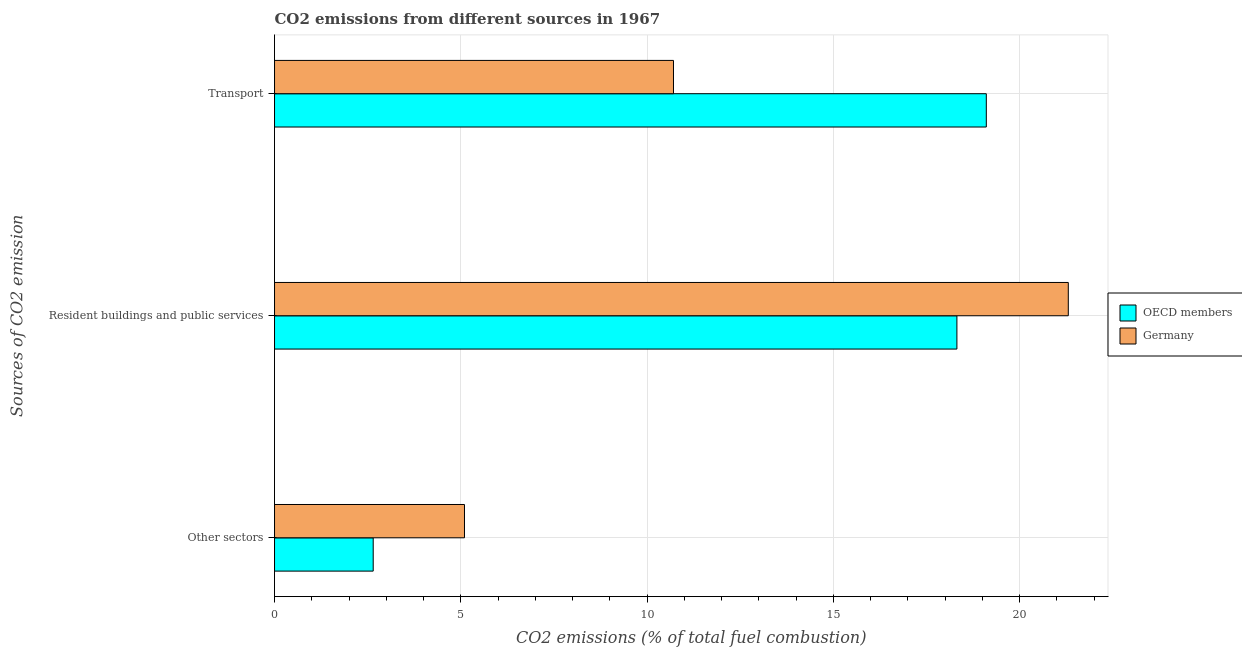How many different coloured bars are there?
Your response must be concise. 2. Are the number of bars on each tick of the Y-axis equal?
Offer a terse response. Yes. How many bars are there on the 2nd tick from the top?
Offer a terse response. 2. What is the label of the 1st group of bars from the top?
Give a very brief answer. Transport. What is the percentage of co2 emissions from resident buildings and public services in OECD members?
Your response must be concise. 18.32. Across all countries, what is the maximum percentage of co2 emissions from transport?
Your answer should be very brief. 19.1. Across all countries, what is the minimum percentage of co2 emissions from resident buildings and public services?
Your answer should be compact. 18.32. What is the total percentage of co2 emissions from transport in the graph?
Ensure brevity in your answer.  29.81. What is the difference between the percentage of co2 emissions from resident buildings and public services in OECD members and that in Germany?
Offer a terse response. -2.99. What is the difference between the percentage of co2 emissions from other sectors in Germany and the percentage of co2 emissions from transport in OECD members?
Offer a terse response. -14.01. What is the average percentage of co2 emissions from transport per country?
Your response must be concise. 14.91. What is the difference between the percentage of co2 emissions from resident buildings and public services and percentage of co2 emissions from transport in Germany?
Make the answer very short. 10.6. What is the ratio of the percentage of co2 emissions from other sectors in Germany to that in OECD members?
Keep it short and to the point. 1.93. Is the percentage of co2 emissions from transport in Germany less than that in OECD members?
Provide a short and direct response. Yes. Is the difference between the percentage of co2 emissions from resident buildings and public services in OECD members and Germany greater than the difference between the percentage of co2 emissions from other sectors in OECD members and Germany?
Offer a very short reply. No. What is the difference between the highest and the second highest percentage of co2 emissions from resident buildings and public services?
Keep it short and to the point. 2.99. What is the difference between the highest and the lowest percentage of co2 emissions from transport?
Your answer should be compact. 8.4. What does the 1st bar from the top in Resident buildings and public services represents?
Offer a terse response. Germany. What does the 1st bar from the bottom in Resident buildings and public services represents?
Offer a terse response. OECD members. Are all the bars in the graph horizontal?
Offer a terse response. Yes. Are the values on the major ticks of X-axis written in scientific E-notation?
Offer a terse response. No. Does the graph contain grids?
Offer a very short reply. Yes. Where does the legend appear in the graph?
Ensure brevity in your answer.  Center right. How many legend labels are there?
Your answer should be very brief. 2. How are the legend labels stacked?
Your answer should be compact. Vertical. What is the title of the graph?
Keep it short and to the point. CO2 emissions from different sources in 1967. Does "Middle East & North Africa (all income levels)" appear as one of the legend labels in the graph?
Your answer should be very brief. No. What is the label or title of the X-axis?
Offer a terse response. CO2 emissions (% of total fuel combustion). What is the label or title of the Y-axis?
Ensure brevity in your answer.  Sources of CO2 emission. What is the CO2 emissions (% of total fuel combustion) in OECD members in Other sectors?
Give a very brief answer. 2.65. What is the CO2 emissions (% of total fuel combustion) in Germany in Other sectors?
Your response must be concise. 5.1. What is the CO2 emissions (% of total fuel combustion) of OECD members in Resident buildings and public services?
Make the answer very short. 18.32. What is the CO2 emissions (% of total fuel combustion) of Germany in Resident buildings and public services?
Keep it short and to the point. 21.31. What is the CO2 emissions (% of total fuel combustion) of OECD members in Transport?
Make the answer very short. 19.1. What is the CO2 emissions (% of total fuel combustion) in Germany in Transport?
Offer a very short reply. 10.71. Across all Sources of CO2 emission, what is the maximum CO2 emissions (% of total fuel combustion) of OECD members?
Provide a short and direct response. 19.1. Across all Sources of CO2 emission, what is the maximum CO2 emissions (% of total fuel combustion) of Germany?
Give a very brief answer. 21.31. Across all Sources of CO2 emission, what is the minimum CO2 emissions (% of total fuel combustion) of OECD members?
Keep it short and to the point. 2.65. Across all Sources of CO2 emission, what is the minimum CO2 emissions (% of total fuel combustion) in Germany?
Your answer should be compact. 5.1. What is the total CO2 emissions (% of total fuel combustion) of OECD members in the graph?
Your answer should be compact. 40.07. What is the total CO2 emissions (% of total fuel combustion) in Germany in the graph?
Your answer should be compact. 37.11. What is the difference between the CO2 emissions (% of total fuel combustion) in OECD members in Other sectors and that in Resident buildings and public services?
Provide a short and direct response. -15.67. What is the difference between the CO2 emissions (% of total fuel combustion) in Germany in Other sectors and that in Resident buildings and public services?
Provide a short and direct response. -16.21. What is the difference between the CO2 emissions (% of total fuel combustion) in OECD members in Other sectors and that in Transport?
Offer a terse response. -16.46. What is the difference between the CO2 emissions (% of total fuel combustion) in Germany in Other sectors and that in Transport?
Offer a terse response. -5.61. What is the difference between the CO2 emissions (% of total fuel combustion) of OECD members in Resident buildings and public services and that in Transport?
Your response must be concise. -0.79. What is the difference between the CO2 emissions (% of total fuel combustion) of Germany in Resident buildings and public services and that in Transport?
Your answer should be very brief. 10.6. What is the difference between the CO2 emissions (% of total fuel combustion) of OECD members in Other sectors and the CO2 emissions (% of total fuel combustion) of Germany in Resident buildings and public services?
Ensure brevity in your answer.  -18.66. What is the difference between the CO2 emissions (% of total fuel combustion) in OECD members in Other sectors and the CO2 emissions (% of total fuel combustion) in Germany in Transport?
Your answer should be very brief. -8.06. What is the difference between the CO2 emissions (% of total fuel combustion) in OECD members in Resident buildings and public services and the CO2 emissions (% of total fuel combustion) in Germany in Transport?
Provide a short and direct response. 7.61. What is the average CO2 emissions (% of total fuel combustion) in OECD members per Sources of CO2 emission?
Provide a succinct answer. 13.36. What is the average CO2 emissions (% of total fuel combustion) in Germany per Sources of CO2 emission?
Provide a succinct answer. 12.37. What is the difference between the CO2 emissions (% of total fuel combustion) of OECD members and CO2 emissions (% of total fuel combustion) of Germany in Other sectors?
Keep it short and to the point. -2.45. What is the difference between the CO2 emissions (% of total fuel combustion) of OECD members and CO2 emissions (% of total fuel combustion) of Germany in Resident buildings and public services?
Your answer should be compact. -2.99. What is the difference between the CO2 emissions (% of total fuel combustion) of OECD members and CO2 emissions (% of total fuel combustion) of Germany in Transport?
Offer a very short reply. 8.4. What is the ratio of the CO2 emissions (% of total fuel combustion) of OECD members in Other sectors to that in Resident buildings and public services?
Your response must be concise. 0.14. What is the ratio of the CO2 emissions (% of total fuel combustion) in Germany in Other sectors to that in Resident buildings and public services?
Offer a very short reply. 0.24. What is the ratio of the CO2 emissions (% of total fuel combustion) of OECD members in Other sectors to that in Transport?
Your answer should be compact. 0.14. What is the ratio of the CO2 emissions (% of total fuel combustion) of Germany in Other sectors to that in Transport?
Your response must be concise. 0.48. What is the ratio of the CO2 emissions (% of total fuel combustion) of OECD members in Resident buildings and public services to that in Transport?
Give a very brief answer. 0.96. What is the ratio of the CO2 emissions (% of total fuel combustion) of Germany in Resident buildings and public services to that in Transport?
Make the answer very short. 1.99. What is the difference between the highest and the second highest CO2 emissions (% of total fuel combustion) of OECD members?
Ensure brevity in your answer.  0.79. What is the difference between the highest and the second highest CO2 emissions (% of total fuel combustion) of Germany?
Provide a short and direct response. 10.6. What is the difference between the highest and the lowest CO2 emissions (% of total fuel combustion) of OECD members?
Provide a short and direct response. 16.46. What is the difference between the highest and the lowest CO2 emissions (% of total fuel combustion) in Germany?
Make the answer very short. 16.21. 